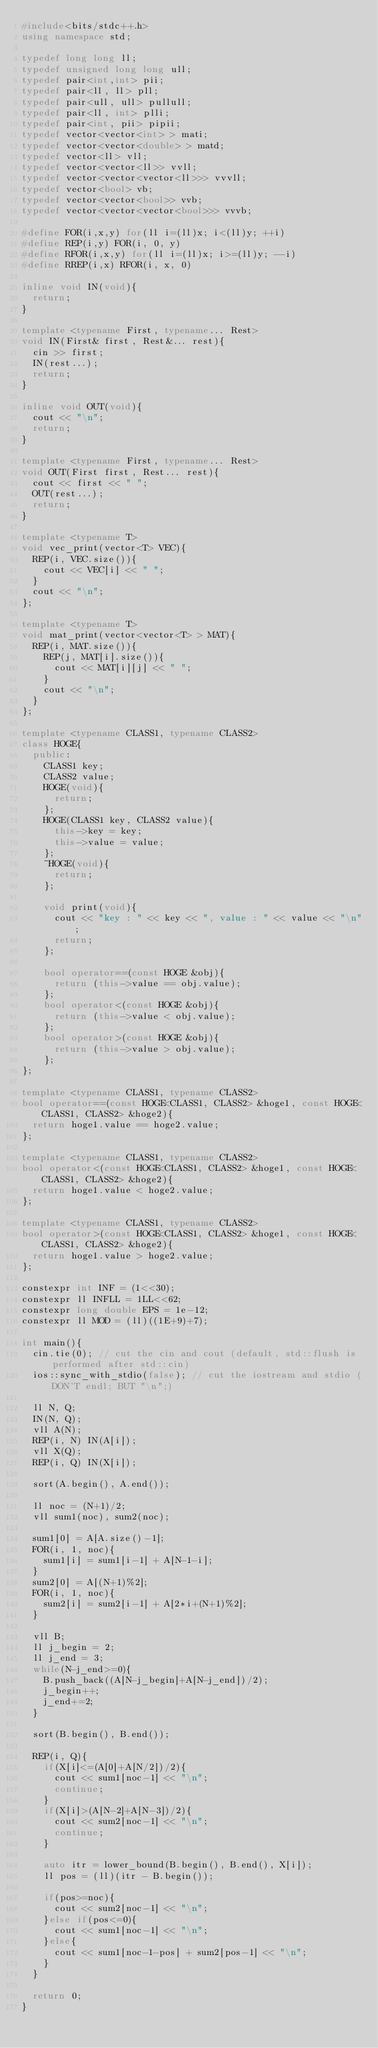<code> <loc_0><loc_0><loc_500><loc_500><_C++_>#include<bits/stdc++.h>
using namespace std;

typedef long long ll;
typedef unsigned long long ull;
typedef pair<int,int> pii;
typedef pair<ll, ll> pll;
typedef pair<ull, ull> pullull;
typedef pair<ll, int> plli;
typedef pair<int, pii> pipii;
typedef vector<vector<int> > mati;
typedef vector<vector<double> > matd;
typedef vector<ll> vll;
typedef vector<vector<ll>> vvll;
typedef vector<vector<vector<ll>>> vvvll;
typedef vector<bool> vb;
typedef vector<vector<bool>> vvb;
typedef vector<vector<vector<bool>>> vvvb;

#define FOR(i,x,y) for(ll i=(ll)x; i<(ll)y; ++i)
#define REP(i,y) FOR(i, 0, y)
#define RFOR(i,x,y) for(ll i=(ll)x; i>=(ll)y; --i)
#define RREP(i,x) RFOR(i, x, 0)

inline void IN(void){
  return;
}

template <typename First, typename... Rest>
void IN(First& first, Rest&... rest){
  cin >> first;
  IN(rest...);
  return;
}

inline void OUT(void){
  cout << "\n";
  return;
}

template <typename First, typename... Rest>
void OUT(First first, Rest... rest){
  cout << first << " ";
  OUT(rest...);
  return;
}

template <typename T>
void vec_print(vector<T> VEC){
  REP(i, VEC.size()){
    cout << VEC[i] << " ";
  }
  cout << "\n";
};

template <typename T>
void mat_print(vector<vector<T> > MAT){
  REP(i, MAT.size()){
    REP(j, MAT[i].size()){
      cout << MAT[i][j] << " ";
    }
    cout << "\n";
  }
};

template <typename CLASS1, typename CLASS2>
class HOGE{
  public:
    CLASS1 key;
    CLASS2 value;
    HOGE(void){
      return;
    };
    HOGE(CLASS1 key, CLASS2 value){
      this->key = key;
      this->value = value;
    };
    ~HOGE(void){
      return;
    };

    void print(void){
      cout << "key : " << key << ", value : " << value << "\n";
      return;
    };
    
    bool operator==(const HOGE &obj){
      return (this->value == obj.value);
    };
    bool operator<(const HOGE &obj){
      return (this->value < obj.value);
    };
    bool operator>(const HOGE &obj){
      return (this->value > obj.value);
    };
};

template <typename CLASS1, typename CLASS2>
bool operator==(const HOGE<CLASS1, CLASS2> &hoge1, const HOGE<CLASS1, CLASS2> &hoge2){
  return hoge1.value == hoge2.value;
};

template <typename CLASS1, typename CLASS2>
bool operator<(const HOGE<CLASS1, CLASS2> &hoge1, const HOGE<CLASS1, CLASS2> &hoge2){
  return hoge1.value < hoge2.value;
};

template <typename CLASS1, typename CLASS2>
bool operator>(const HOGE<CLASS1, CLASS2> &hoge1, const HOGE<CLASS1, CLASS2> &hoge2){
  return hoge1.value > hoge2.value;
};

constexpr int INF = (1<<30);
constexpr ll INFLL = 1LL<<62;
constexpr long double EPS = 1e-12;
constexpr ll MOD = (ll)((1E+9)+7);

int main(){
  cin.tie(0); // cut the cin and cout (default, std::flush is performed after std::cin)
  ios::sync_with_stdio(false); // cut the iostream and stdio (DON'T endl; BUT "\n";)

  ll N, Q;
  IN(N, Q);
  vll A(N);
  REP(i, N) IN(A[i]);
  vll X(Q);
  REP(i, Q) IN(X[i]);

  sort(A.begin(), A.end());

  ll noc = (N+1)/2;
  vll sum1(noc), sum2(noc);

  sum1[0] = A[A.size()-1];
  FOR(i, 1, noc){
    sum1[i] = sum1[i-1] + A[N-1-i];
  }
  sum2[0] = A[(N+1)%2];
  FOR(i, 1, noc){
    sum2[i] = sum2[i-1] + A[2*i+(N+1)%2];
  }

  vll B;
  ll j_begin = 2;
  ll j_end = 3;
  while(N-j_end>=0){
    B.push_back((A[N-j_begin]+A[N-j_end])/2);
    j_begin++;
    j_end+=2;
  }

  sort(B.begin(), B.end());

  REP(i, Q){
    if(X[i]<=(A[0]+A[N/2])/2){
      cout << sum1[noc-1] << "\n";
      continue;
    }
    if(X[i]>(A[N-2]+A[N-3])/2){
      cout << sum2[noc-1] << "\n";
      continue;
    }

    auto itr = lower_bound(B.begin(), B.end(), X[i]);
    ll pos = (ll)(itr - B.begin());

    if(pos>=noc){
      cout << sum2[noc-1] << "\n";
    }else if(pos<=0){
      cout << sum1[noc-1] << "\n";
    }else{
      cout << sum1[noc-1-pos] + sum2[pos-1] << "\n";
    }
  }

  return 0;
}</code> 